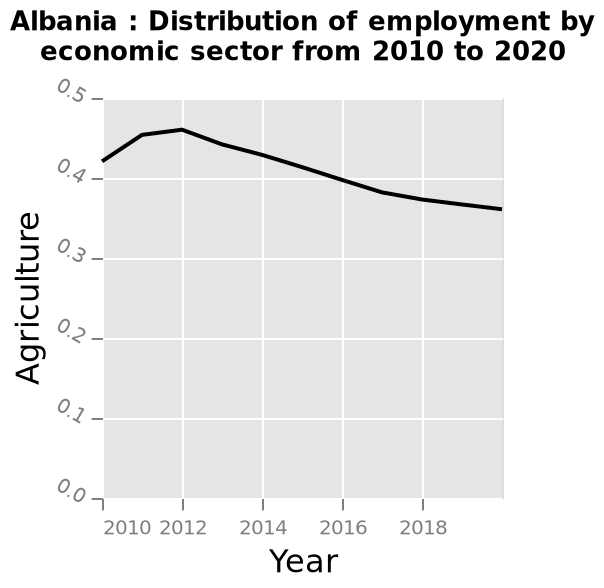<image>
What does the line plot represent? The line plot represents the distribution of employment by economic sector in Albania from 2010 to 2020. What is the range of the x-axis? The x-axis ranges from 2010 to 2018, representing the years. please describe the details of the chart Here a line plot is called Albania : Distribution of employment by economic sector from 2010 to 2020. There is a linear scale with a minimum of 0.0 and a maximum of 0.5 along the y-axis, marked Agriculture. The x-axis shows Year along a linear scale with a minimum of 2010 and a maximum of 2018. 